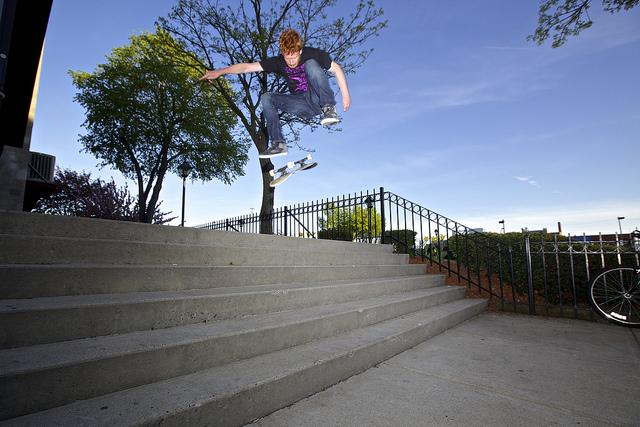If the skateboard kept this orientation how would his landing be? Please explain your reasoning. dangerous. The wheels need to point down. 